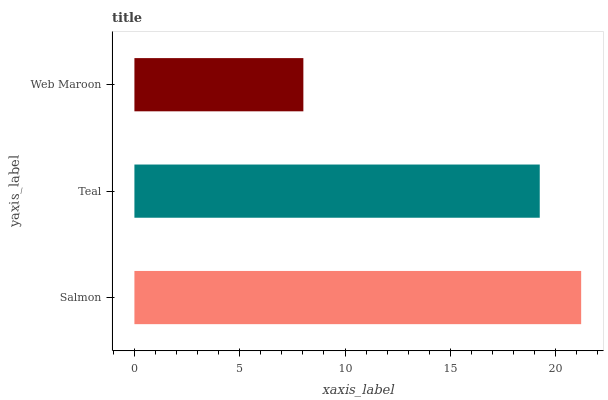Is Web Maroon the minimum?
Answer yes or no. Yes. Is Salmon the maximum?
Answer yes or no. Yes. Is Teal the minimum?
Answer yes or no. No. Is Teal the maximum?
Answer yes or no. No. Is Salmon greater than Teal?
Answer yes or no. Yes. Is Teal less than Salmon?
Answer yes or no. Yes. Is Teal greater than Salmon?
Answer yes or no. No. Is Salmon less than Teal?
Answer yes or no. No. Is Teal the high median?
Answer yes or no. Yes. Is Teal the low median?
Answer yes or no. Yes. Is Web Maroon the high median?
Answer yes or no. No. Is Web Maroon the low median?
Answer yes or no. No. 